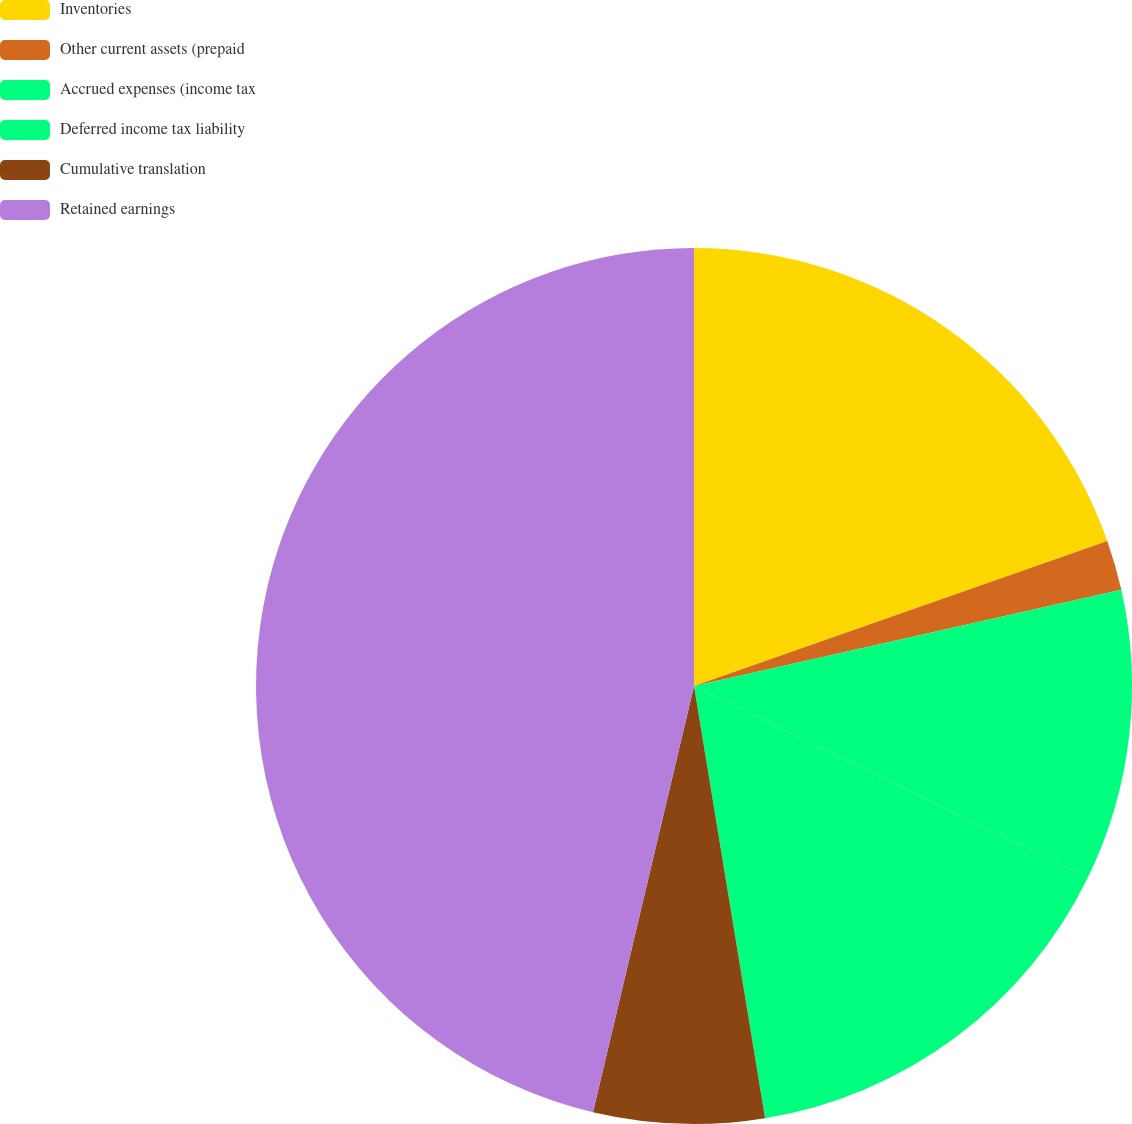Convert chart to OTSL. <chart><loc_0><loc_0><loc_500><loc_500><pie_chart><fcel>Inventories<fcel>Other current assets (prepaid<fcel>Accrued expenses (income tax<fcel>Deferred income tax liability<fcel>Cumulative translation<fcel>Retained earnings<nl><fcel>19.63%<fcel>1.85%<fcel>10.74%<fcel>15.19%<fcel>6.3%<fcel>46.3%<nl></chart> 